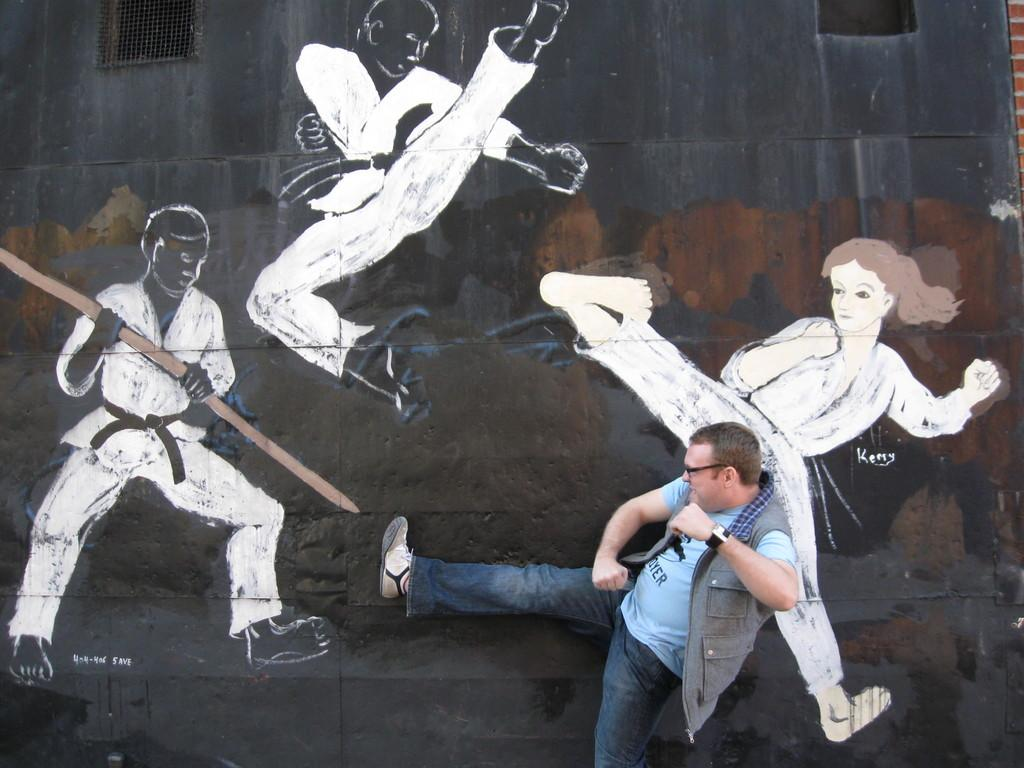What is the main subject of the image? There is a man in the image. What can be seen on the wall in the image? There is a painting of people on the wall. Can you describe any other objects or features in the image? There is a mesh in the image. What type of animals can be seen in the zoo in the image? There is no zoo present in the image. 